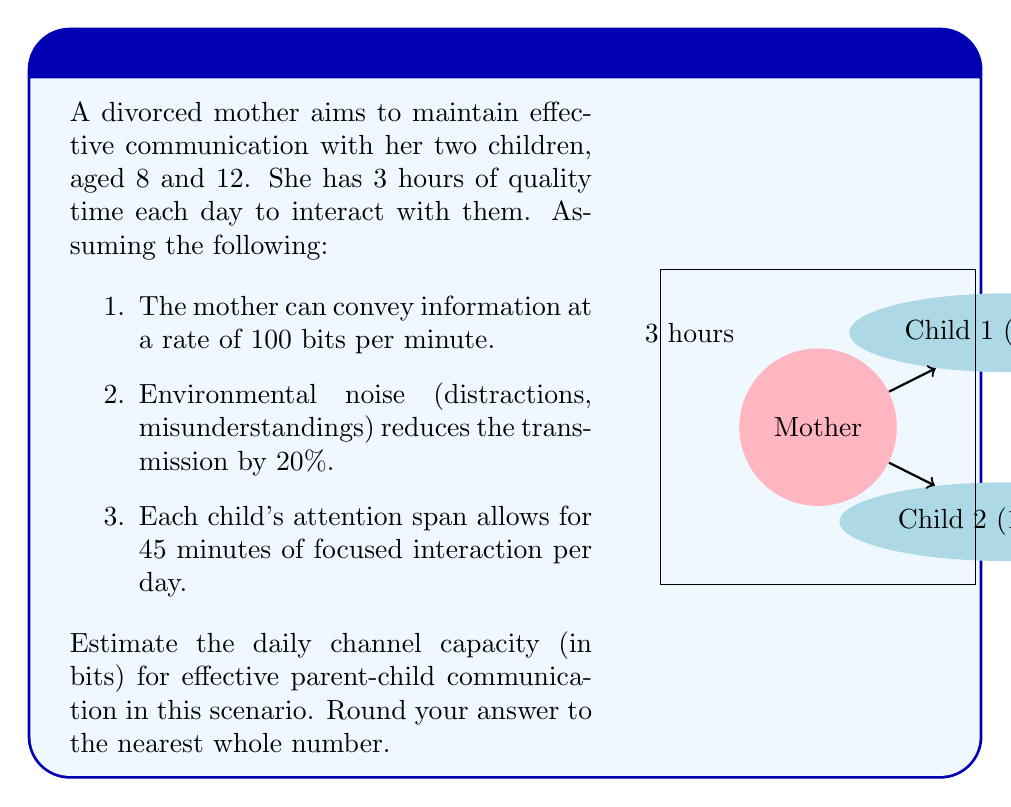Show me your answer to this math problem. Let's approach this problem step-by-step:

1) First, calculate the total bits the mother can transmit in 3 hours:
   $$3 \text{ hours} \times 60 \text{ minutes/hour} \times 100 \text{ bits/minute} = 18,000 \text{ bits}$$

2) Account for the 20% reduction due to environmental noise:
   $$18,000 \text{ bits} \times (1 - 0.2) = 14,400 \text{ bits}$$

3) Now, consider the children's attention spans. Each child can focus for 45 minutes per day. The total focused interaction time is:
   $$45 \text{ minutes} \times 2 \text{ children} = 90 \text{ minutes}$$

4) Calculate the bits transmitted during the focused interaction time:
   $$90 \text{ minutes} \times 100 \text{ bits/minute} = 9,000 \text{ bits}$$

5) Apply the 20% reduction to this focused communication:
   $$9,000 \text{ bits} \times (1 - 0.2) = 7,200 \text{ bits}$$

6) The channel capacity is the minimum of the mother's total communication capacity and the children's focused reception capacity:
   $$\min(14,400 \text{ bits}, 7,200 \text{ bits}) = 7,200 \text{ bits}$$

Therefore, the estimated daily channel capacity for effective parent-child communication in this scenario is 7,200 bits.
Answer: 7,200 bits 